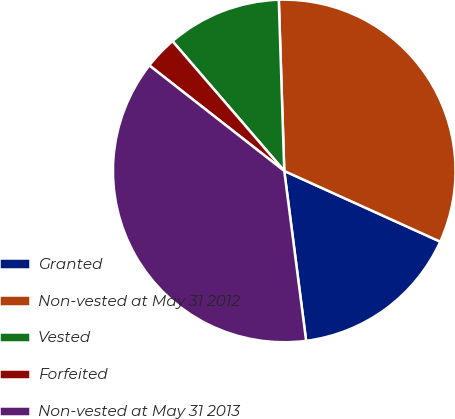<chart> <loc_0><loc_0><loc_500><loc_500><pie_chart><fcel>Granted<fcel>Non-vested at May 31 2012<fcel>Vested<fcel>Forfeited<fcel>Non-vested at May 31 2013<nl><fcel>16.19%<fcel>32.28%<fcel>10.81%<fcel>3.12%<fcel>37.6%<nl></chart> 